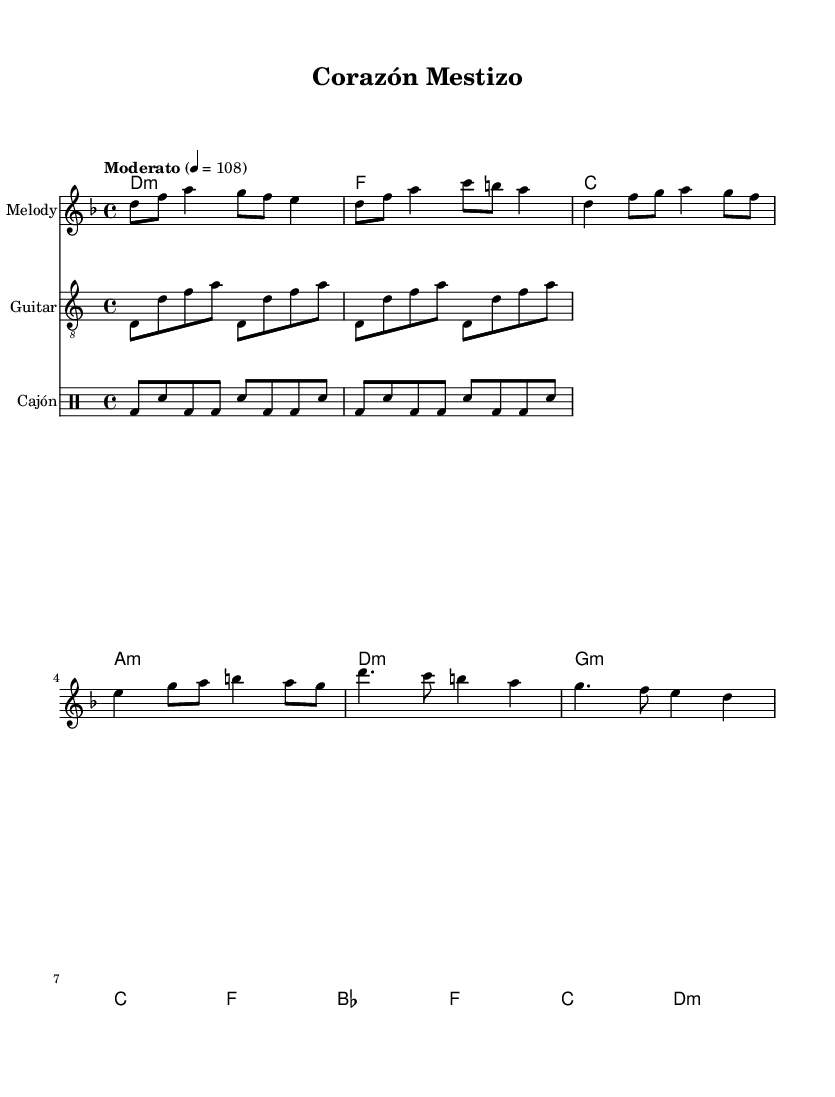What is the key signature of this music? The key signature is D minor, which has one flat (B flat), indicated by the presence of a flat sign at the beginning of the staff.
Answer: D minor What is the time signature of this composition? The time signature is 4/4, which means there are four beats in a measure and the quarter note receives one beat. This is indicated at the beginning of the score.
Answer: 4/4 What is the tempo marking for this piece? The tempo marking is "Moderato," indicating a moderate tempo, which is typically around 108 beats per minute. This can be found in the header section of the score.
Answer: Moderato How many measures are there in the chorus section? The chorus section consists of 4 measures, as can be observed by counting the measure lines or bars within this section of the sheet music.
Answer: 4 What instruments are included in this piece? The instruments included are Melody, Guitar, and Cajón. This information can be found in the staff labels at the beginning of each musical line.
Answer: Melody, Guitar, Cajón How does the harmony change in the verse section? The harmony changes from D minor to G minor, then to C major, and finally to F major in the verse section. This is determined by analyzing the chord progression indicated below the melody.
Answer: D minor to G minor to C major to F major What type of rhythm is used in the Cajón part? The rhythm used in the Cajón part is a repeated pattern of bass drum and snare hits, characterized by alternating bass and snare notes through the measures. This is visible in the drummode section where the notes are laid out.
Answer: Bass and snare rhythm 